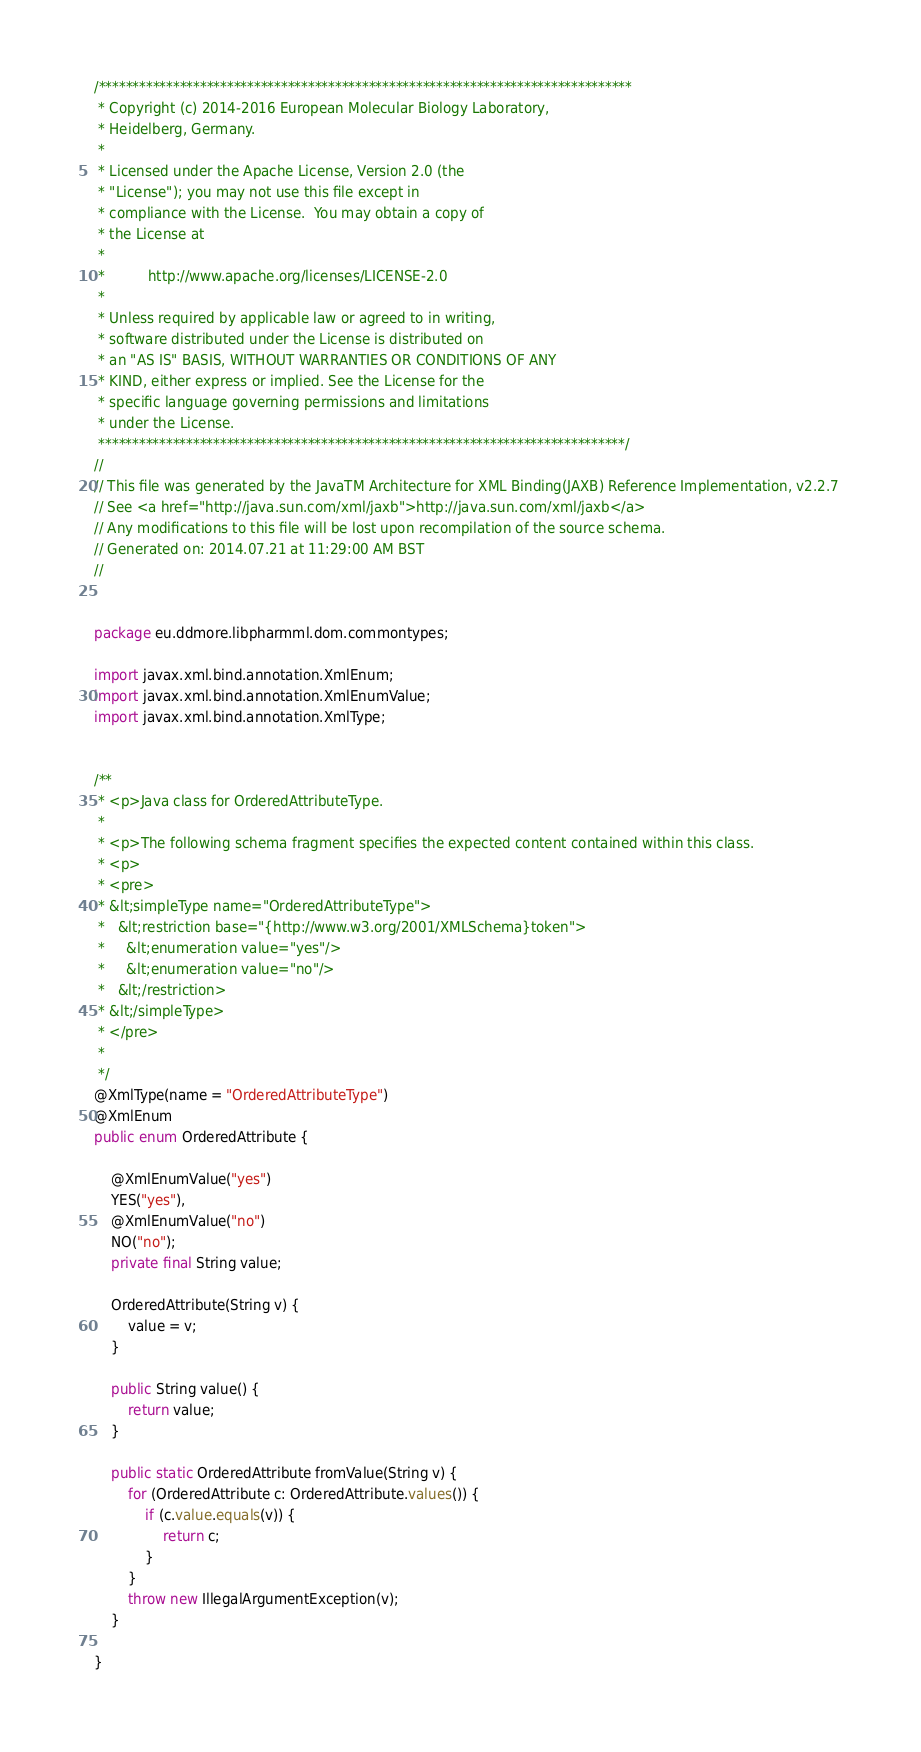Convert code to text. <code><loc_0><loc_0><loc_500><loc_500><_Java_>/*******************************************************************************
 * Copyright (c) 2014-2016 European Molecular Biology Laboratory,
 * Heidelberg, Germany.
 * 
 * Licensed under the Apache License, Version 2.0 (the
 * "License"); you may not use this file except in
 * compliance with the License.  You may obtain a copy of
 * the License at
 * 
 *  		http://www.apache.org/licenses/LICENSE-2.0
 * 
 * Unless required by applicable law or agreed to in writing, 
 * software distributed under the License is distributed on 
 * an "AS IS" BASIS, WITHOUT WARRANTIES OR CONDITIONS OF ANY 
 * KIND, either express or implied. See the License for the 
 * specific language governing permissions and limitations 
 * under the License.
 ******************************************************************************/
//
// This file was generated by the JavaTM Architecture for XML Binding(JAXB) Reference Implementation, v2.2.7 
// See <a href="http://java.sun.com/xml/jaxb">http://java.sun.com/xml/jaxb</a> 
// Any modifications to this file will be lost upon recompilation of the source schema. 
// Generated on: 2014.07.21 at 11:29:00 AM BST 
//


package eu.ddmore.libpharmml.dom.commontypes;

import javax.xml.bind.annotation.XmlEnum;
import javax.xml.bind.annotation.XmlEnumValue;
import javax.xml.bind.annotation.XmlType;


/**
 * <p>Java class for OrderedAttributeType.
 * 
 * <p>The following schema fragment specifies the expected content contained within this class.
 * <p>
 * <pre>
 * &lt;simpleType name="OrderedAttributeType">
 *   &lt;restriction base="{http://www.w3.org/2001/XMLSchema}token">
 *     &lt;enumeration value="yes"/>
 *     &lt;enumeration value="no"/>
 *   &lt;/restriction>
 * &lt;/simpleType>
 * </pre>
 * 
 */
@XmlType(name = "OrderedAttributeType")
@XmlEnum
public enum OrderedAttribute {

    @XmlEnumValue("yes")
    YES("yes"),
    @XmlEnumValue("no")
    NO("no");
    private final String value;

    OrderedAttribute(String v) {
        value = v;
    }

    public String value() {
        return value;
    }

    public static OrderedAttribute fromValue(String v) {
        for (OrderedAttribute c: OrderedAttribute.values()) {
            if (c.value.equals(v)) {
                return c;
            }
        }
        throw new IllegalArgumentException(v);
    }

}
</code> 